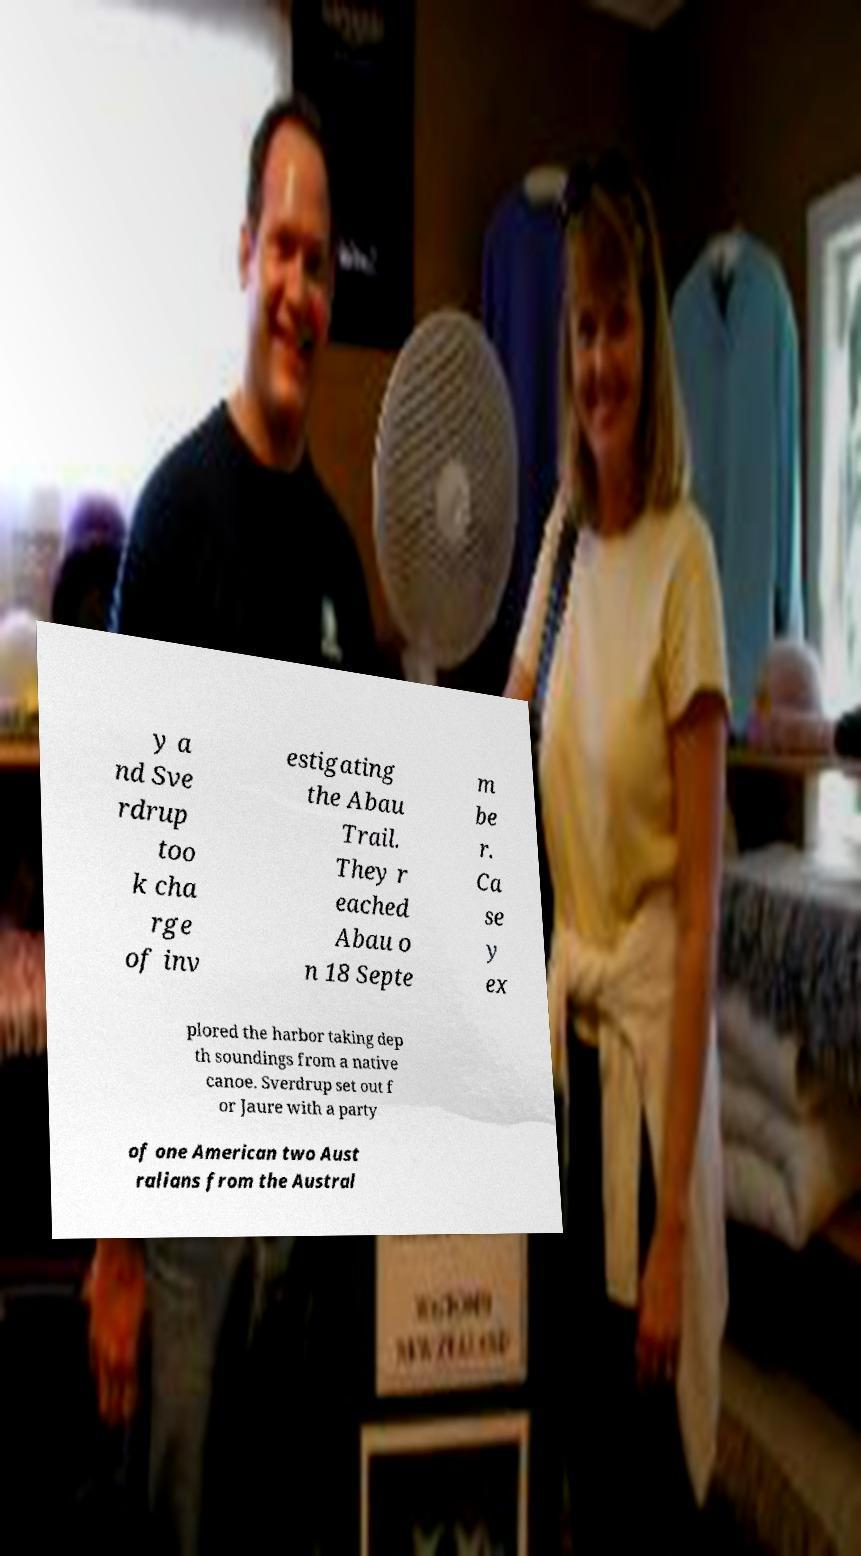There's text embedded in this image that I need extracted. Can you transcribe it verbatim? y a nd Sve rdrup too k cha rge of inv estigating the Abau Trail. They r eached Abau o n 18 Septe m be r. Ca se y ex plored the harbor taking dep th soundings from a native canoe. Sverdrup set out f or Jaure with a party of one American two Aust ralians from the Austral 